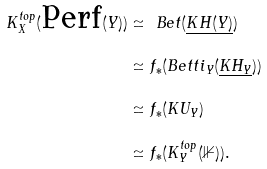Convert formula to latex. <formula><loc_0><loc_0><loc_500><loc_500>K ^ { t o p } _ { X } ( \text {Perf} ( Y ) ) & \simeq \ B e t ( \underline { K H ( Y ) } ) \\ & \simeq f _ { * } ( B e t t i _ { Y } ( \underline { K H _ { Y } } ) ) \\ & \simeq f _ { * } ( K U _ { Y } ) \\ & \simeq f _ { * } ( K ^ { t o p } _ { Y } ( \mathbb { 1 } ) ) .</formula> 